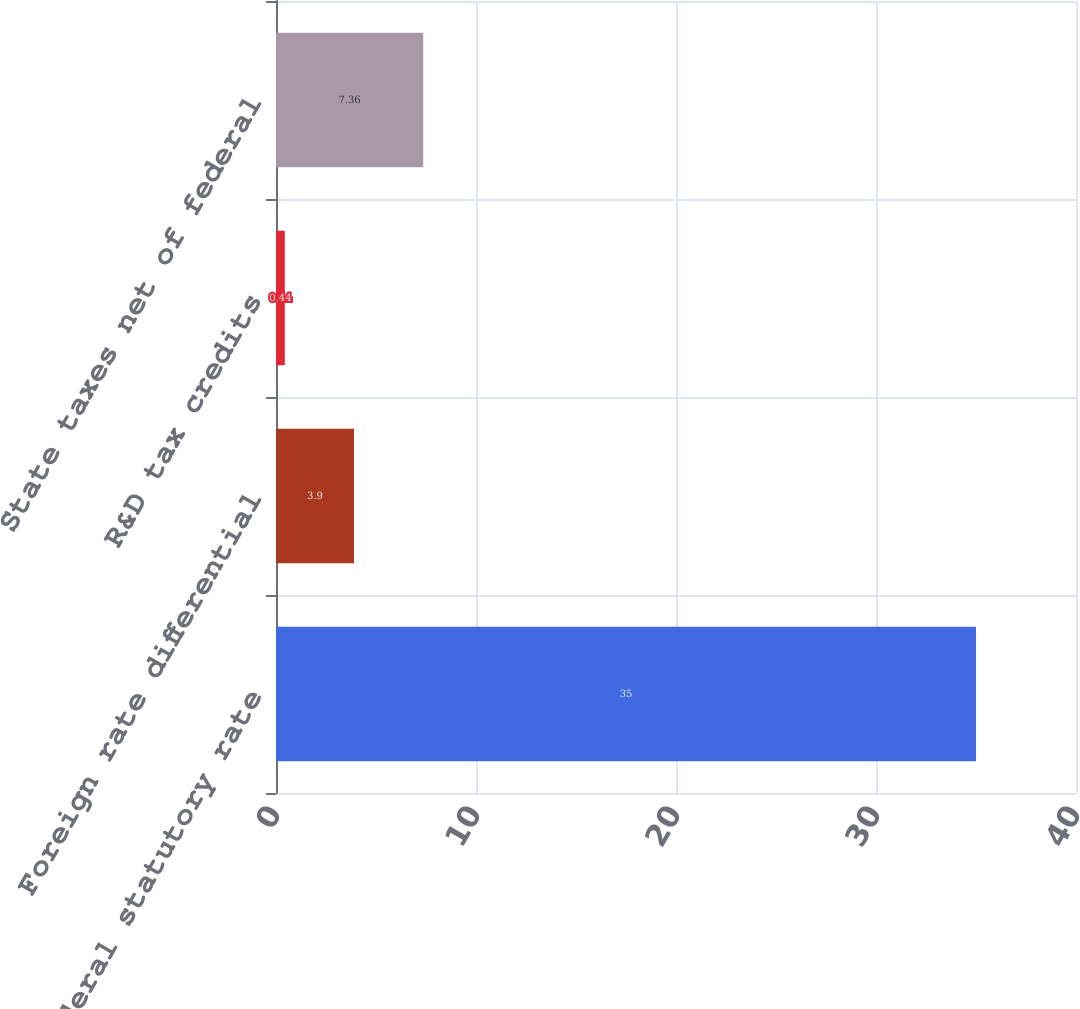Convert chart to OTSL. <chart><loc_0><loc_0><loc_500><loc_500><bar_chart><fcel>Federal statutory rate<fcel>Foreign rate differential<fcel>R&D tax credits<fcel>State taxes net of federal<nl><fcel>35<fcel>3.9<fcel>0.44<fcel>7.36<nl></chart> 